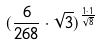Convert formula to latex. <formula><loc_0><loc_0><loc_500><loc_500>( \frac { 6 } { 2 6 8 } \cdot \sqrt { 3 } ) ^ { \frac { 1 \cdot 1 } { \sqrt { 8 } } }</formula> 